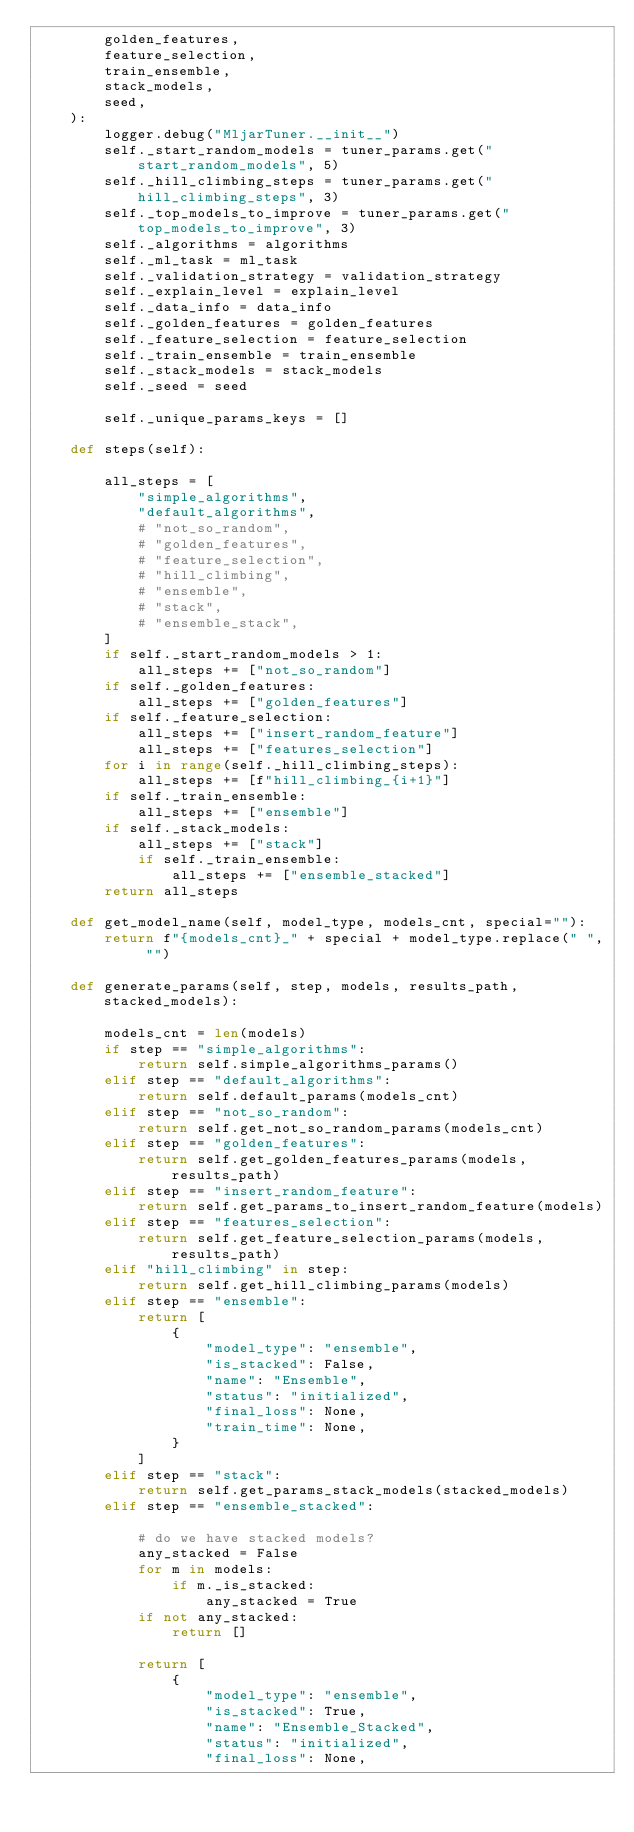Convert code to text. <code><loc_0><loc_0><loc_500><loc_500><_Python_>        golden_features,
        feature_selection,
        train_ensemble,
        stack_models,
        seed,
    ):
        logger.debug("MljarTuner.__init__")
        self._start_random_models = tuner_params.get("start_random_models", 5)
        self._hill_climbing_steps = tuner_params.get("hill_climbing_steps", 3)
        self._top_models_to_improve = tuner_params.get("top_models_to_improve", 3)
        self._algorithms = algorithms
        self._ml_task = ml_task
        self._validation_strategy = validation_strategy
        self._explain_level = explain_level
        self._data_info = data_info
        self._golden_features = golden_features
        self._feature_selection = feature_selection
        self._train_ensemble = train_ensemble
        self._stack_models = stack_models
        self._seed = seed

        self._unique_params_keys = []

    def steps(self):

        all_steps = [
            "simple_algorithms",
            "default_algorithms",
            # "not_so_random",
            # "golden_features",
            # "feature_selection",
            # "hill_climbing",
            # "ensemble",
            # "stack",
            # "ensemble_stack",
        ]
        if self._start_random_models > 1:
            all_steps += ["not_so_random"]
        if self._golden_features:
            all_steps += ["golden_features"]
        if self._feature_selection:
            all_steps += ["insert_random_feature"]
            all_steps += ["features_selection"]
        for i in range(self._hill_climbing_steps):
            all_steps += [f"hill_climbing_{i+1}"]
        if self._train_ensemble:
            all_steps += ["ensemble"]
        if self._stack_models:
            all_steps += ["stack"]
            if self._train_ensemble:
                all_steps += ["ensemble_stacked"]
        return all_steps

    def get_model_name(self, model_type, models_cnt, special=""):
        return f"{models_cnt}_" + special + model_type.replace(" ", "")

    def generate_params(self, step, models, results_path, stacked_models):

        models_cnt = len(models)
        if step == "simple_algorithms":
            return self.simple_algorithms_params()
        elif step == "default_algorithms":
            return self.default_params(models_cnt)
        elif step == "not_so_random":
            return self.get_not_so_random_params(models_cnt)
        elif step == "golden_features":
            return self.get_golden_features_params(models, results_path)
        elif step == "insert_random_feature":
            return self.get_params_to_insert_random_feature(models)
        elif step == "features_selection":
            return self.get_feature_selection_params(models, results_path)
        elif "hill_climbing" in step:
            return self.get_hill_climbing_params(models)
        elif step == "ensemble":
            return [
                {
                    "model_type": "ensemble",
                    "is_stacked": False,
                    "name": "Ensemble",
                    "status": "initialized",
                    "final_loss": None,
                    "train_time": None,
                }
            ]
        elif step == "stack":
            return self.get_params_stack_models(stacked_models)
        elif step == "ensemble_stacked":

            # do we have stacked models?
            any_stacked = False
            for m in models:
                if m._is_stacked:
                    any_stacked = True
            if not any_stacked:
                return []

            return [
                {
                    "model_type": "ensemble",
                    "is_stacked": True,
                    "name": "Ensemble_Stacked",
                    "status": "initialized",
                    "final_loss": None,</code> 